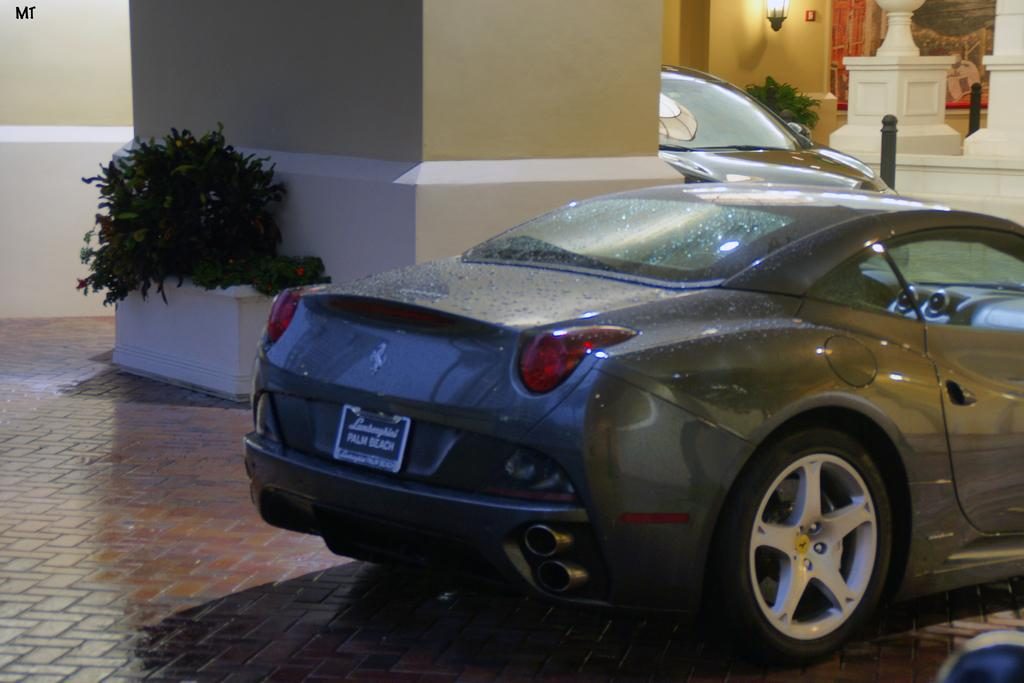What types of objects are present in the image? There are vehicles, pillars, plants in pots, a wall with lights, and poles in the image. What can be seen on the ground in the image? The ground is visible in the image. What is attached to the wall in the image? There are posters on the wall. What type of mist can be seen surrounding the vehicles in the image? There is no mist present in the image; it features vehicles, pillars, plants in pots, a wall with lights, and poles. Can you tell me how many mittens are hanging from the poles in the image? There are no mittens present in the image; it features vehicles, pillars, plants in pots, a wall with lights, and poles. 